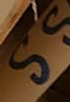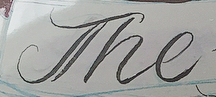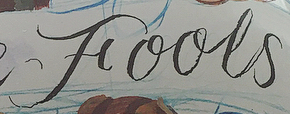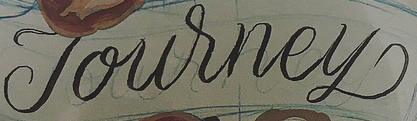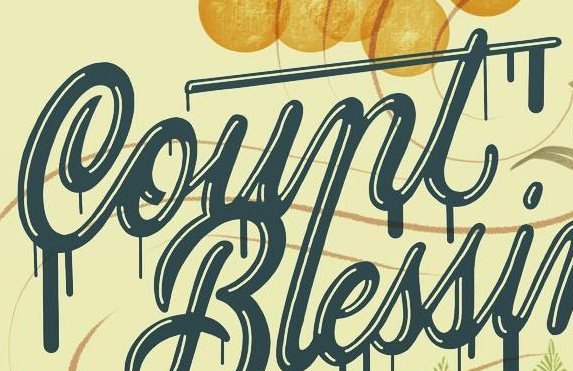What words can you see in these images in sequence, separated by a semicolon? SS; The; Fools; Journey; Count 